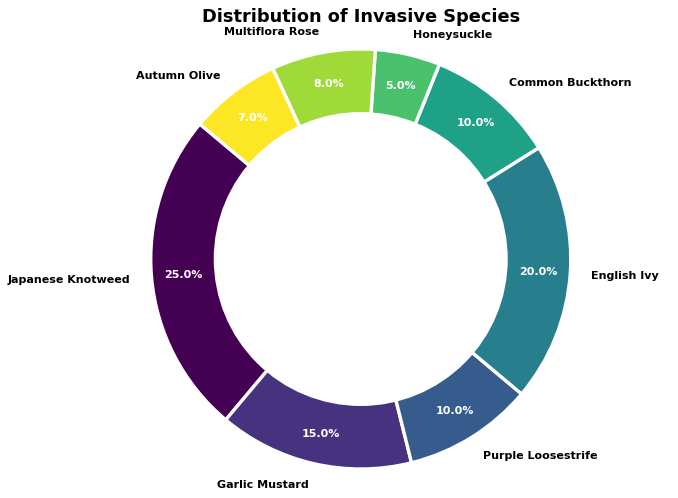What's the most prevalent invasive species in the figure? The invading species with the largest percentage slice in the ring chart is the most prevalent. The chart shows Japanese Knotweed having the largest slice at 25%.
Answer: Japanese Knotweed Which two invasive species have an equal percentage of distribution? We look for species with the same size of the slices. The chart shows Purple Loosestrife and Common Buckthorn each occupying 10% of the distribution.
Answer: Purple Loosestrife and Common Buckthorn What is the combined percentage of Japanese Knotweed and English Ivy? To find the combined percentage, add the individual percentages of Japanese Knotweed and English Ivy. Japanese Knotweed is 25% and English Ivy is 20%, so 25% + 20% = 45%.
Answer: 45% Which species has the smallest presence, and what is its percentage? The smallest presence will be the species with the smallest slice in the ring chart. Honeysuckle has the smallest slice, with a presence of 5%.
Answer: Honeysuckle, 5% What is the difference in percentage between Garlic Mustard and Autumn Olive? Subtract the percentage of Autumn Olive from that of Garlic Mustard. Garlic Mustard is 15% and Autumn Olive is 7%, so 15% - 7% = 8%.
Answer: 8% How many species have a distribution percentage greater than or equal to 10%? Count the slices in the ring chart that are labeled with percentages of 10% or greater. Japanese Knotweed (25%), Garlic Mustard (15%), English Ivy (20%), Purple Loosestrife (10%), and Common Buckthorn (10%) total up to five species.
Answer: 5 Which species occupies a middle-ground percentage, neither the highest nor the lowest? Inspect the chart to find a species with a percentage that is neither the highest (25%, Japanese Knotweed) nor the lowest (5%, Honeysuckle). English Ivy (20%) fits as a middle-ground percentage.
Answer: English Ivy Between Multiflora Rose and Autumn Olive, which one has a higher distribution percentage? Compare the percentages of Multiflora Rose and Autumn Olive. Multiflora Rose is at 8% while Autumn Olive is at 7%, thus Multiflora Rose has a higher distribution.
Answer: Multiflora Rose 